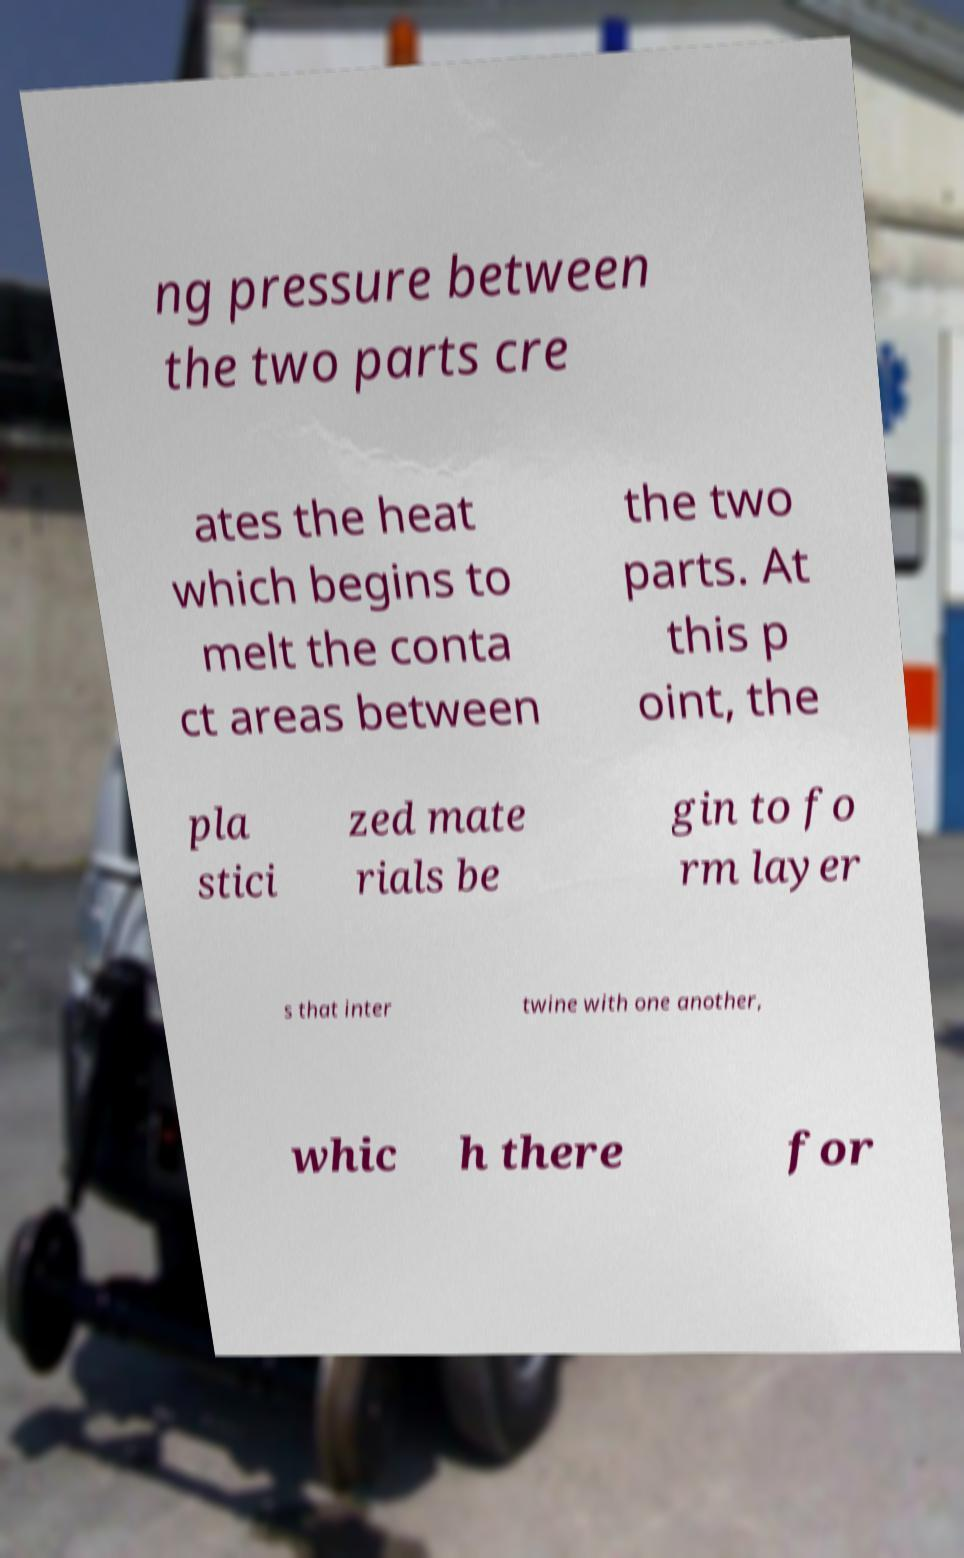For documentation purposes, I need the text within this image transcribed. Could you provide that? ng pressure between the two parts cre ates the heat which begins to melt the conta ct areas between the two parts. At this p oint, the pla stici zed mate rials be gin to fo rm layer s that inter twine with one another, whic h there for 